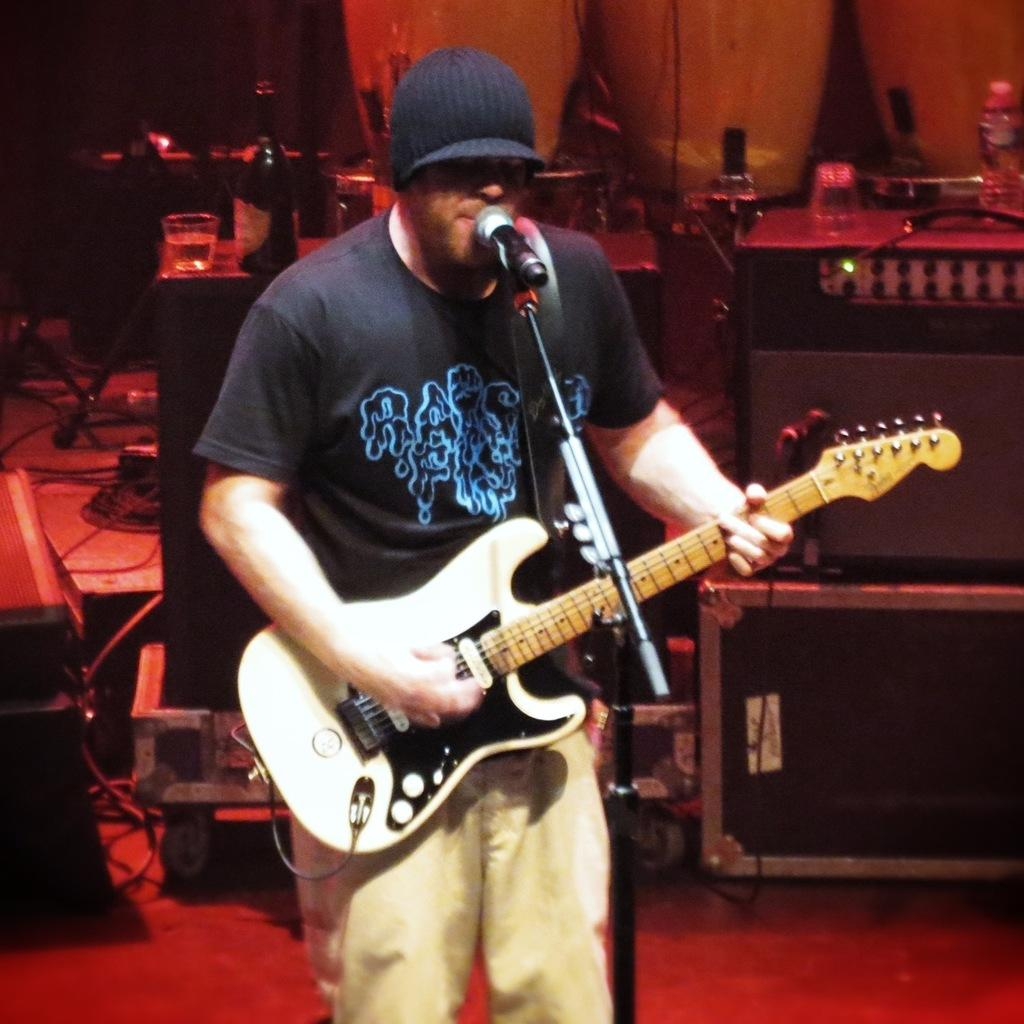What is the man in the image holding? The man is holding a guitar. What is the man standing near in the image? The man is standing in front of a microphone. What can be seen in the background of the image? There is equipment visible in the background of the image. How many bottles are present in the image? There are two bottles in the image. Can you see the man's son playing with a gun in the image? There is no child or gun present in the image. 